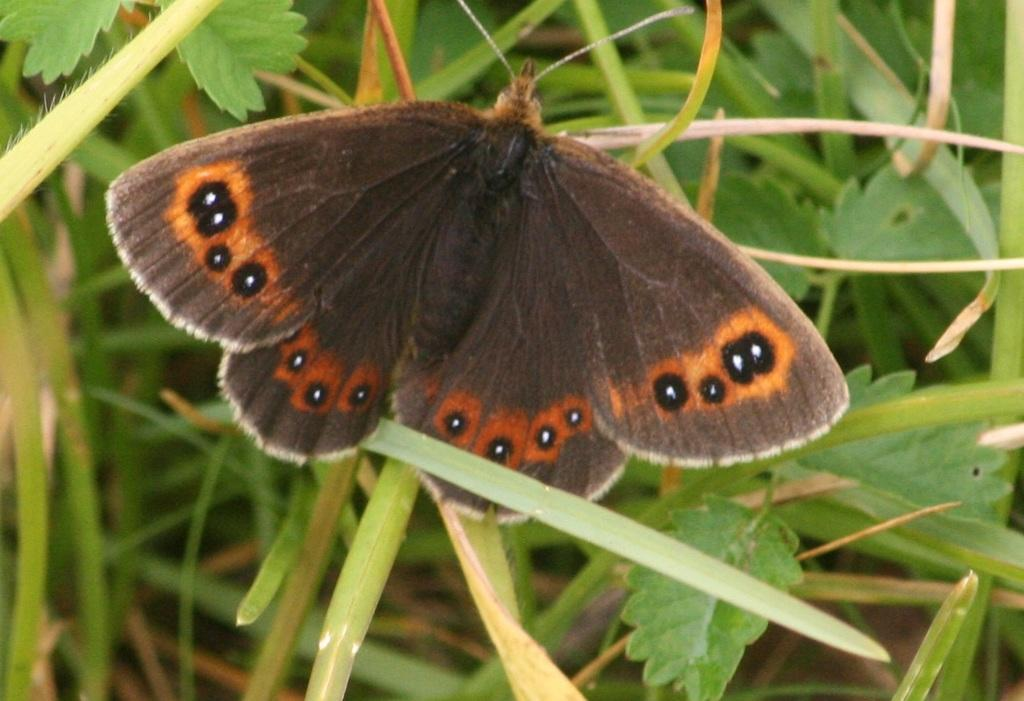What is the main subject of the image? There is a butterfly in the image. Where is the butterfly located in the image? The butterfly is in the front of the image. What can be seen in the background of the image? There are leaves in the background of the image. What type of noise does the donkey make in the image? There is no donkey present in the image, so it is not possible to determine what noise it might make. 